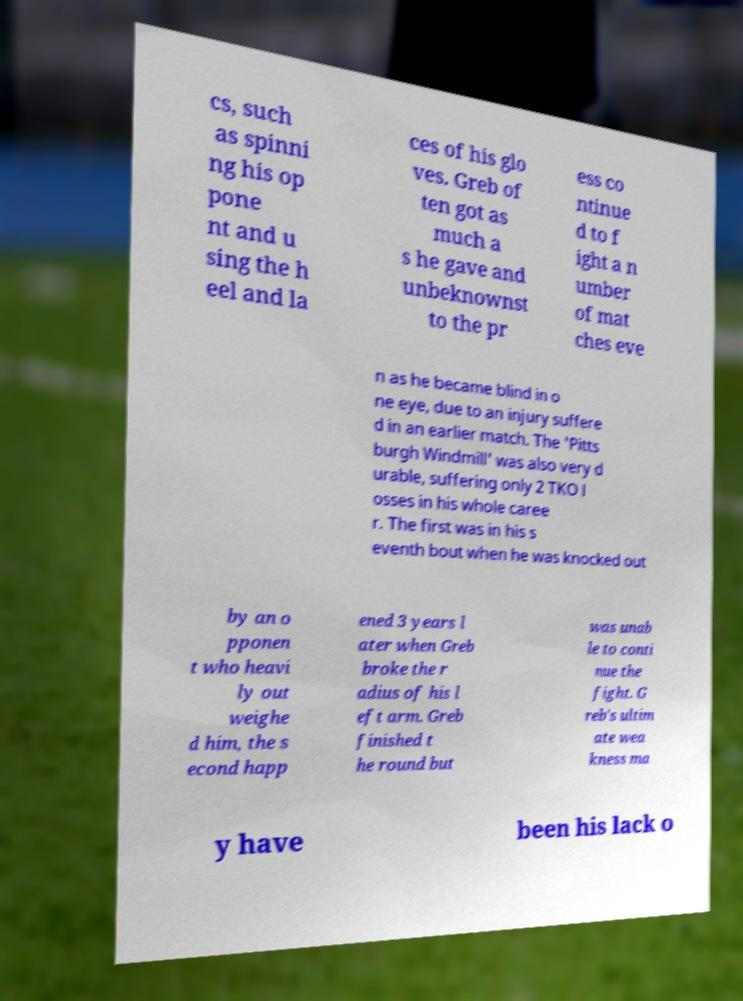Could you extract and type out the text from this image? cs, such as spinni ng his op pone nt and u sing the h eel and la ces of his glo ves. Greb of ten got as much a s he gave and unbeknownst to the pr ess co ntinue d to f ight a n umber of mat ches eve n as he became blind in o ne eye, due to an injury suffere d in an earlier match. The 'Pitts burgh Windmill' was also very d urable, suffering only 2 TKO l osses in his whole caree r. The first was in his s eventh bout when he was knocked out by an o pponen t who heavi ly out weighe d him, the s econd happ ened 3 years l ater when Greb broke the r adius of his l eft arm. Greb finished t he round but was unab le to conti nue the fight. G reb's ultim ate wea kness ma y have been his lack o 